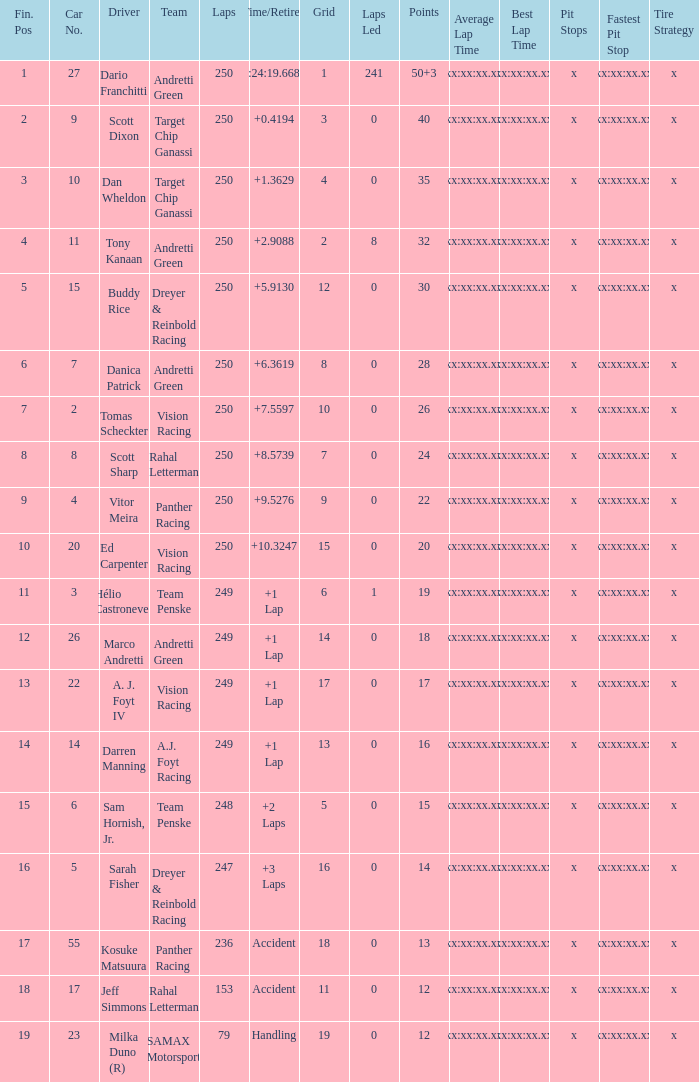What is the sum of cars from panther racing and a 9-car grid? 1.0. 